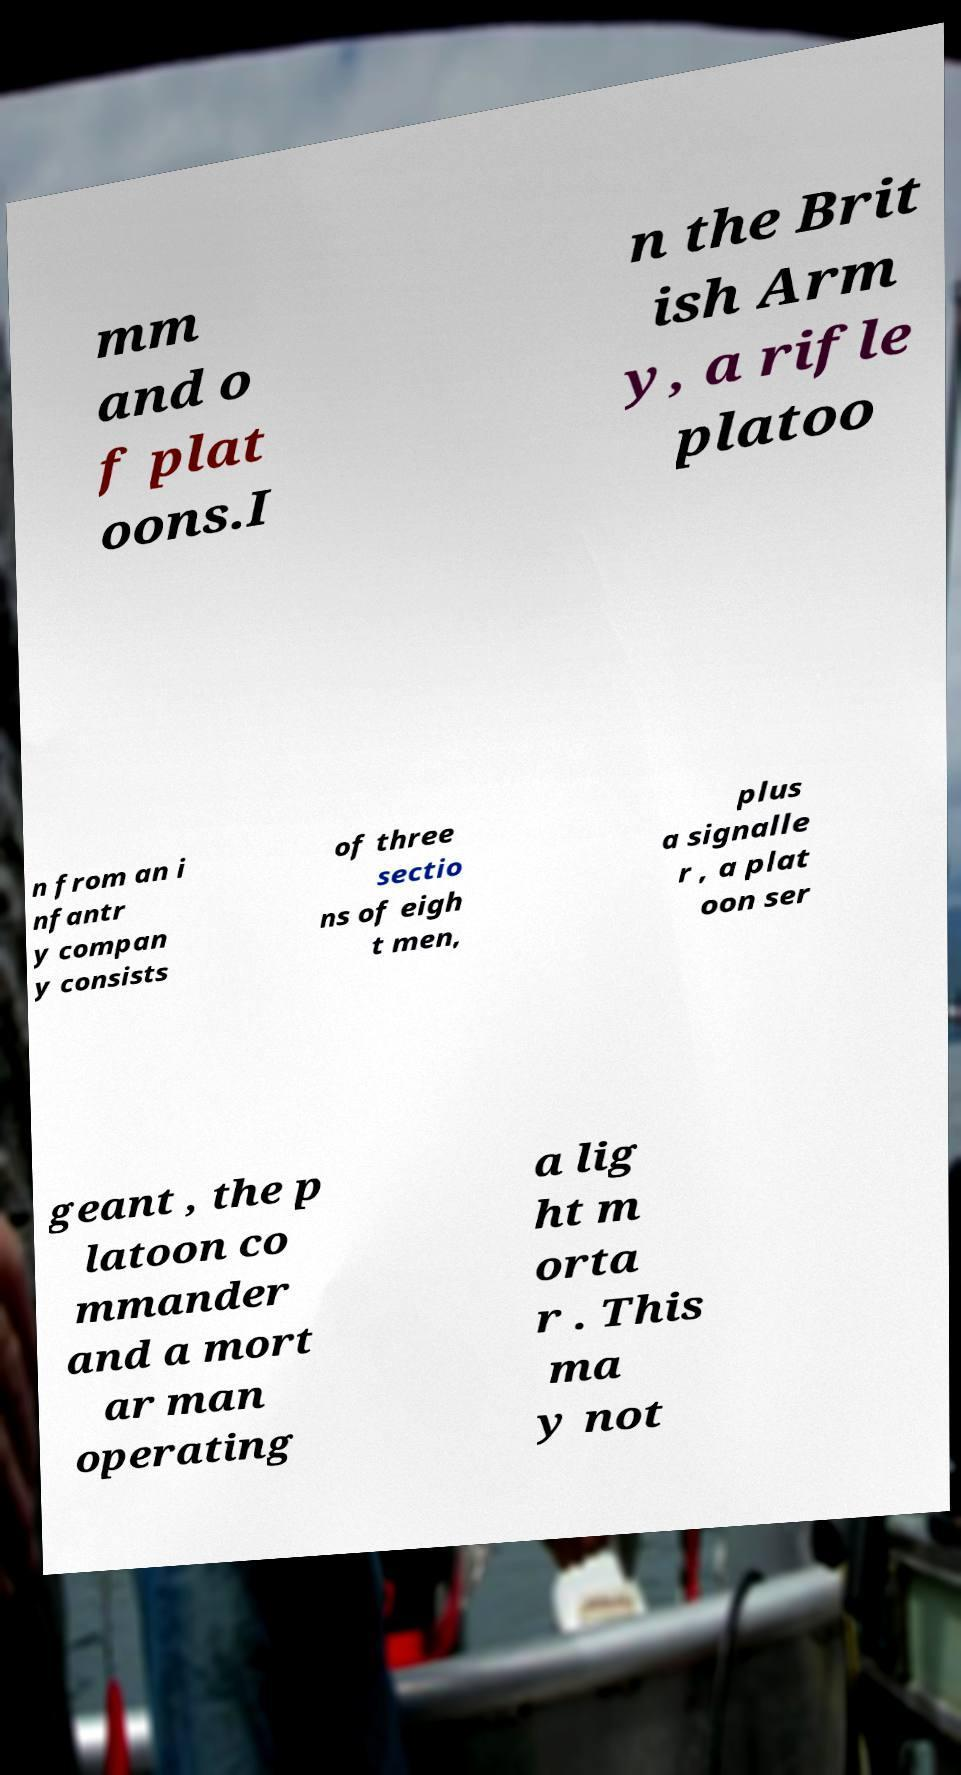Can you read and provide the text displayed in the image?This photo seems to have some interesting text. Can you extract and type it out for me? mm and o f plat oons.I n the Brit ish Arm y, a rifle platoo n from an i nfantr y compan y consists of three sectio ns of eigh t men, plus a signalle r , a plat oon ser geant , the p latoon co mmander and a mort ar man operating a lig ht m orta r . This ma y not 